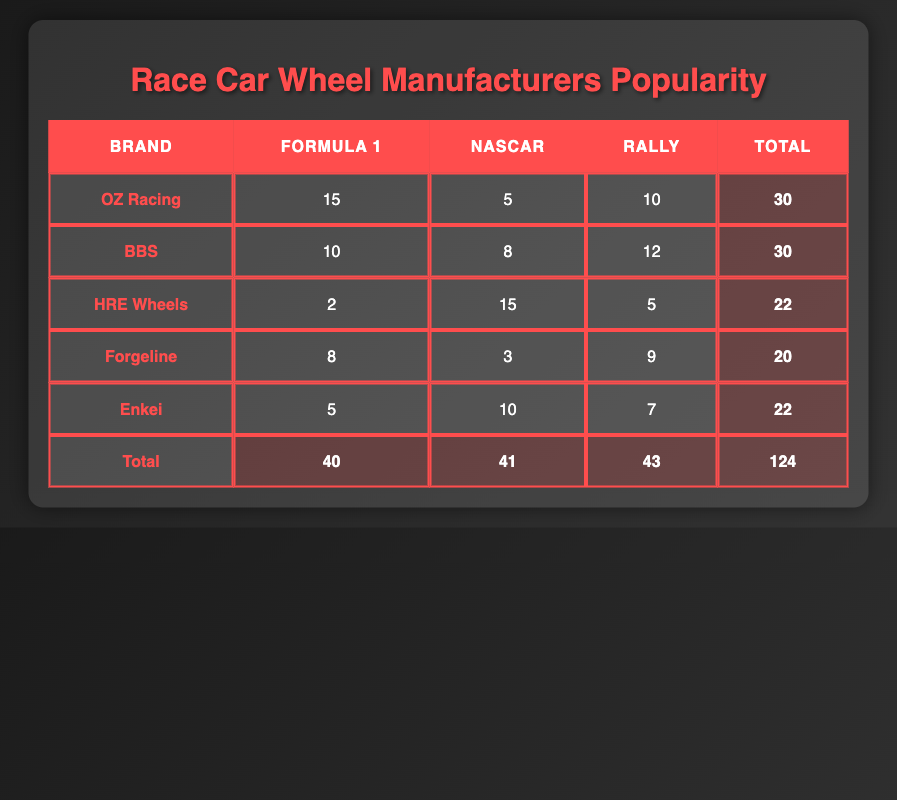What is the total popularity count for BBS? BBS has popularity counts of 10 in Formula 1, 8 in NASCAR, and 12 in Rally. By summing these counts, we get 10 + 8 + 12 = 30.
Answer: 30 Which brand is more popular in NASCAR, HRE Wheels or Forgeline? HRE Wheels has a popularity count of 15 in NASCAR, while Forgeline has a count of 3. Since 15 > 3, HRE Wheels is more popular in NASCAR.
Answer: HRE Wheels What is the total number of popularity counts across all categories for all brands? The total counts for each brand are 30 (OZ Racing) + 30 (BBS) + 22 (HRE Wheels) + 20 (Forgeline) + 22 (Enkei) = 124.
Answer: 124 Is the popularity of Enkei in Rally greater than that of OZ Racing? Enkei has a popularity count of 7 in Rally, while OZ Racing has a count of 10. Since 7 is not greater than 10, the statement is false.
Answer: No What is the average popularity count in Formula 1 among the brands? The counts in Formula 1 are 15 (OZ Racing), 10 (BBS), 2 (HRE Wheels), 8 (Forgeline), and 5 (Enkei). Summing these gives 15 + 10 + 2 + 8 + 5 = 40. There are 5 brands, so the average is 40/5 = 8.
Answer: 8 Which manufacturer has the highest total popularity? The total popularity counts are as follows: OZ Racing - 30, BBS - 30, HRE Wheels - 22, Forgeline - 20, and Enkei - 22. The highest total counts are 30 for both OZ Racing and BBS.
Answer: OZ Racing and BBS Which racing category has the highest total popularity across all brands? The counts for each category are Formula 1: 40, NASCAR: 41, and Rally: 43. The highest total is in Rally with a count of 43.
Answer: Rally What is the difference in total popularity between Formula 1 and NASCAR? The total popularity for Formula 1 is 40 and for NASCAR is 41. The difference is calculated as 41 - 40 = 1.
Answer: 1 Which brand has the highest popularity in Rally? The popularity counts in Rally are: OZ Racing - 10, BBS - 12, HRE Wheels - 5, Forgeline - 9, and Enkei - 7. BBS has the highest count of 12.
Answer: BBS 